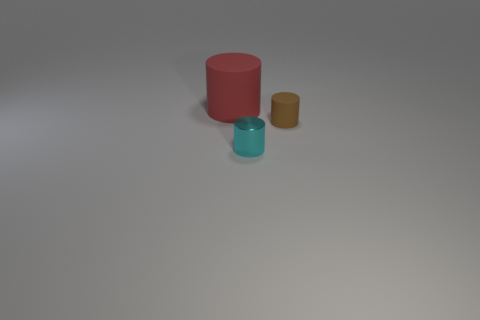Subtract all tiny cylinders. How many cylinders are left? 1 Add 1 big blocks. How many objects exist? 4 Subtract all red cylinders. How many cylinders are left? 2 Subtract all purple cylinders. Subtract all purple cubes. How many cylinders are left? 3 Subtract all purple spheres. How many purple cylinders are left? 0 Subtract all big yellow metallic blocks. Subtract all cyan cylinders. How many objects are left? 2 Add 1 cylinders. How many cylinders are left? 4 Add 1 tiny green metal cubes. How many tiny green metal cubes exist? 1 Subtract 1 cyan cylinders. How many objects are left? 2 